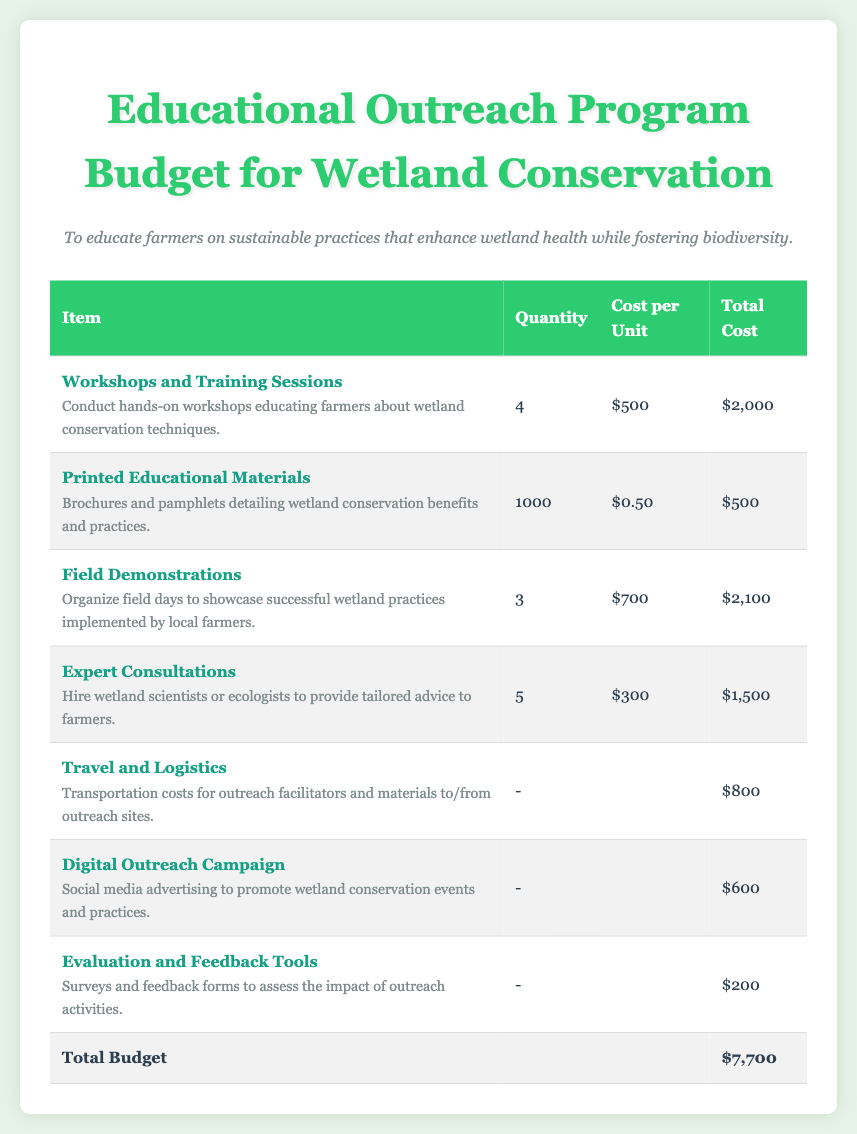what is the total budget? The total budget is the sum of all expenses listed in the document, amounting to $7,700.
Answer: $7,700 how many workshops are planned? The document states that there will be 4 workshops conducted as part of the outreach program.
Answer: 4 what is the cost per unit for printed educational materials? The cost per unit for printed educational materials, such as brochures and pamphlets, is specified as $0.50.
Answer: $0.50 what is the primary objective of the program? The objective outlined in the document is to educate farmers on sustainable practices that enhance wetland health while fostering biodiversity.
Answer: To educate farmers on sustainable practices how many field demonstrations will be organized? According to the document, there will be 3 field demonstrations organized to showcase successful wetland practices.
Answer: 3 what is the total cost for expert consultations? The total cost for hiring wetland scientists or ecologists, as mentioned, is $1,500.
Answer: $1,500 how much is allocated for travel and logistics? The budget allocates $800 specifically for transportation costs related to outreach activities.
Answer: $800 what is included in the evaluation and feedback tools? The evaluation and feedback tools consist of surveys and feedback forms to assess the impact of outreach activities.
Answer: Surveys and feedback forms how much will be spent on the digital outreach campaign? The cost for the digital outreach campaign for social media advertising is noted as $600 in the budget.
Answer: $600 